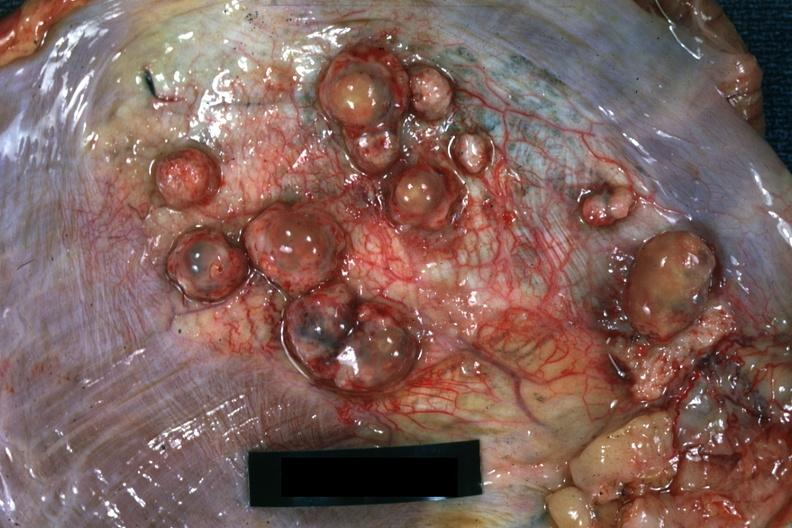s soft tissue present?
Answer the question using a single word or phrase. Yes 